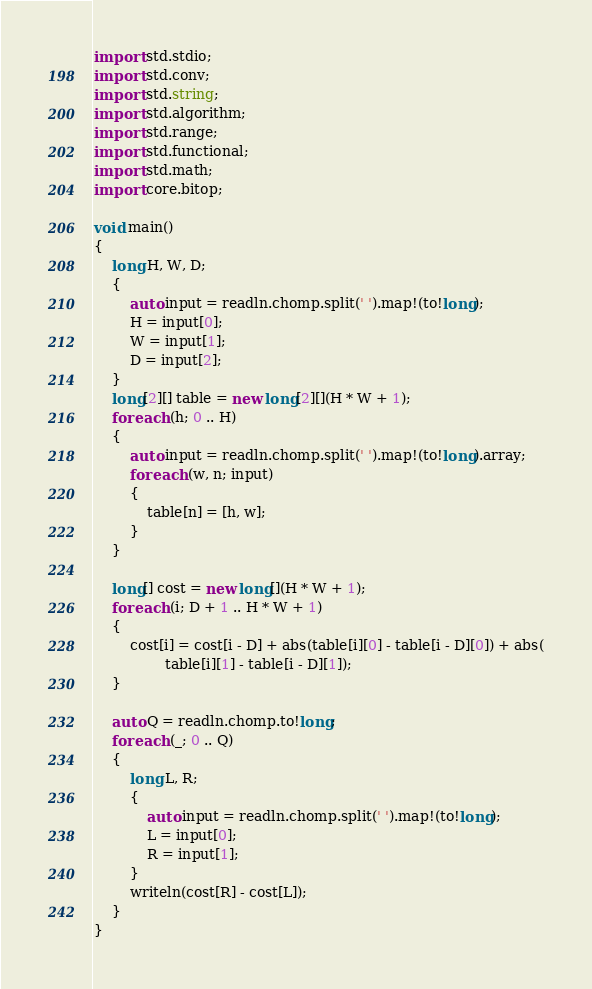<code> <loc_0><loc_0><loc_500><loc_500><_D_>import std.stdio;
import std.conv;
import std.string;
import std.algorithm;
import std.range;
import std.functional;
import std.math;
import core.bitop;

void main()
{
    long H, W, D;
    {
        auto input = readln.chomp.split(' ').map!(to!long);
        H = input[0];
        W = input[1];
        D = input[2];
    }
    long[2][] table = new long[2][](H * W + 1);
    foreach (h; 0 .. H)
    {
        auto input = readln.chomp.split(' ').map!(to!long).array;
        foreach (w, n; input)
        {
            table[n] = [h, w];
        }
    }

    long[] cost = new long[](H * W + 1);
    foreach (i; D + 1 .. H * W + 1)
    {
        cost[i] = cost[i - D] + abs(table[i][0] - table[i - D][0]) + abs(
                table[i][1] - table[i - D][1]);
    }

    auto Q = readln.chomp.to!long;
    foreach (_; 0 .. Q)
    {
        long L, R;
        {
            auto input = readln.chomp.split(' ').map!(to!long);
            L = input[0];
            R = input[1];
        }
        writeln(cost[R] - cost[L]);
    }
}
</code> 